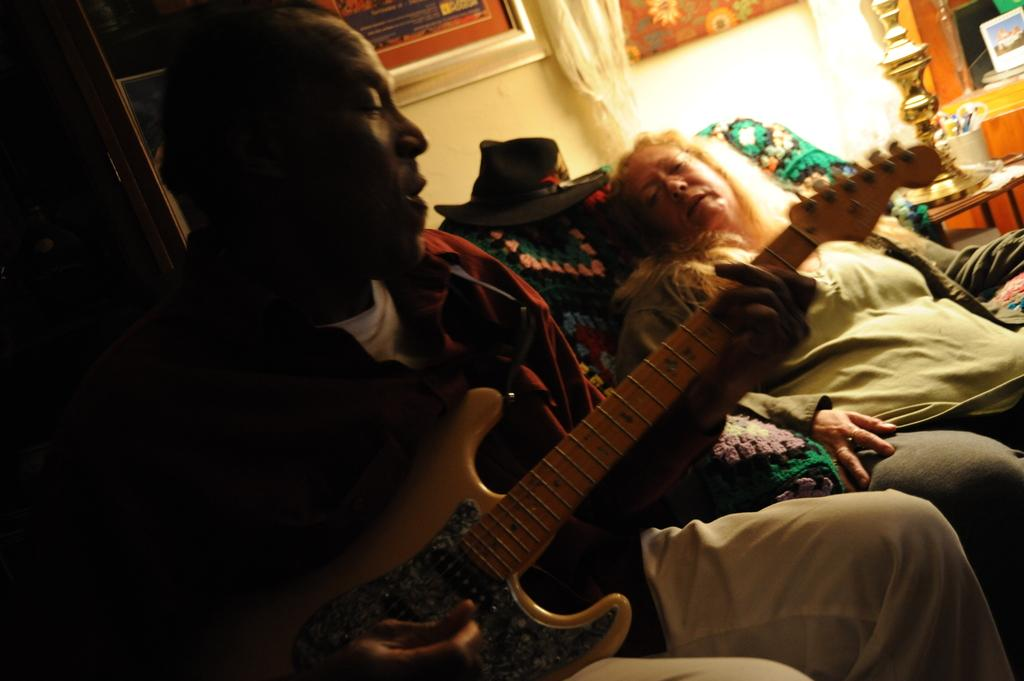How many people are in the image? There are two persons in the image. What are the two persons doing in the image? The two persons are sitting on a sofa. What is the man on the left side holding in his hands? The man on the left side is holding a guitar in his hands. What type of work is the grandmother doing in the image? There is no grandmother present in the image, and therefore no work can be attributed to her. Where is the camp located in the image? There is no camp present in the image. 